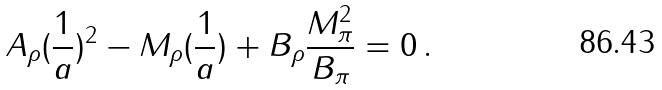<formula> <loc_0><loc_0><loc_500><loc_500>A _ { \rho } ( \frac { 1 } { a } ) ^ { 2 } - M _ { \rho } ( \frac { 1 } { a } ) + B _ { \rho } \frac { M _ { \pi } ^ { 2 } } { B _ { \pi } } = 0 \, .</formula> 